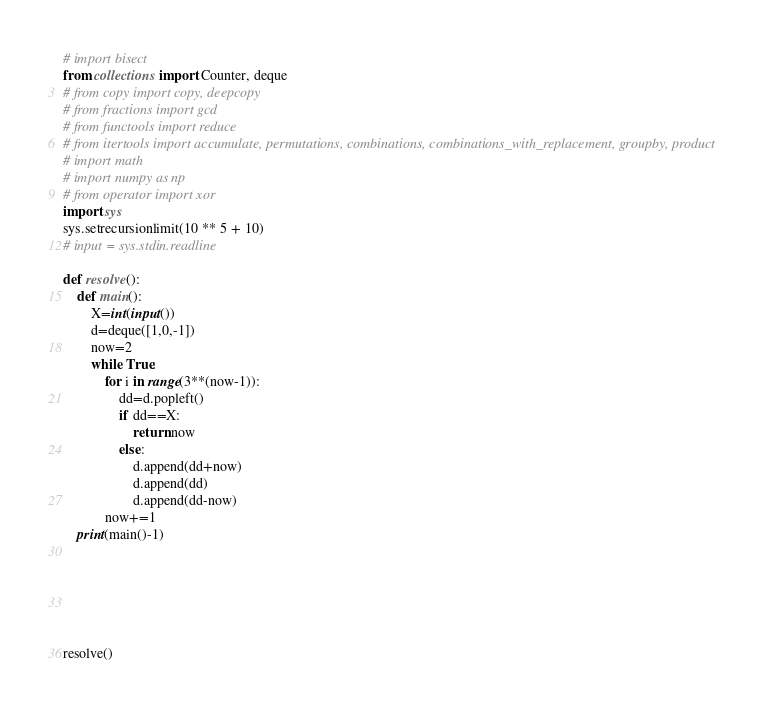Convert code to text. <code><loc_0><loc_0><loc_500><loc_500><_Python_># import bisect
from collections import Counter, deque
# from copy import copy, deepcopy
# from fractions import gcd
# from functools import reduce
# from itertools import accumulate, permutations, combinations, combinations_with_replacement, groupby, product
# import math
# import numpy as np
# from operator import xor
import sys
sys.setrecursionlimit(10 ** 5 + 10)
# input = sys.stdin.readline

def resolve():
    def main():
        X=int(input())
        d=deque([1,0,-1])
        now=2
        while True:
            for i in range(3**(now-1)):
                dd=d.popleft()
                if dd==X:
                    return now
                else:
                    d.append(dd+now)
                    d.append(dd)
                    d.append(dd-now)
            now+=1
    print(main()-1)






resolve()</code> 